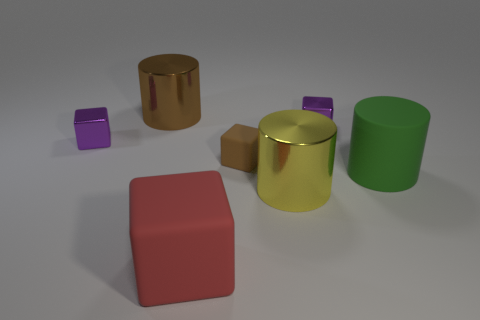Subtract all large rubber cylinders. How many cylinders are left? 2 Add 2 gray spheres. How many objects exist? 9 Subtract all red cubes. How many cubes are left? 3 Subtract all cylinders. How many objects are left? 4 Subtract 1 cubes. How many cubes are left? 3 Subtract 1 brown cubes. How many objects are left? 6 Subtract all brown blocks. Subtract all blue balls. How many blocks are left? 3 Subtract all red cylinders. How many purple cubes are left? 2 Subtract all gray metal blocks. Subtract all red things. How many objects are left? 6 Add 3 big objects. How many big objects are left? 7 